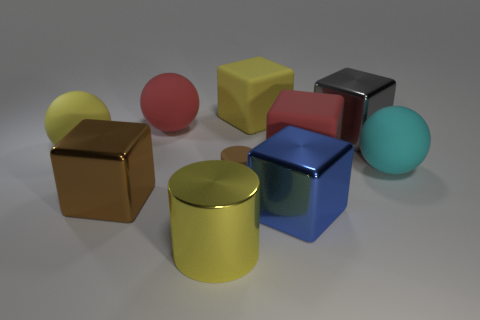Subtract all blue metallic cubes. How many cubes are left? 4 Subtract all gray blocks. How many blocks are left? 4 Subtract all balls. How many objects are left? 7 Subtract all green cubes. Subtract all gray spheres. How many cubes are left? 5 Subtract 0 green cubes. How many objects are left? 10 Subtract all matte blocks. Subtract all red rubber objects. How many objects are left? 6 Add 3 brown shiny objects. How many brown shiny objects are left? 4 Add 6 brown shiny things. How many brown shiny things exist? 7 